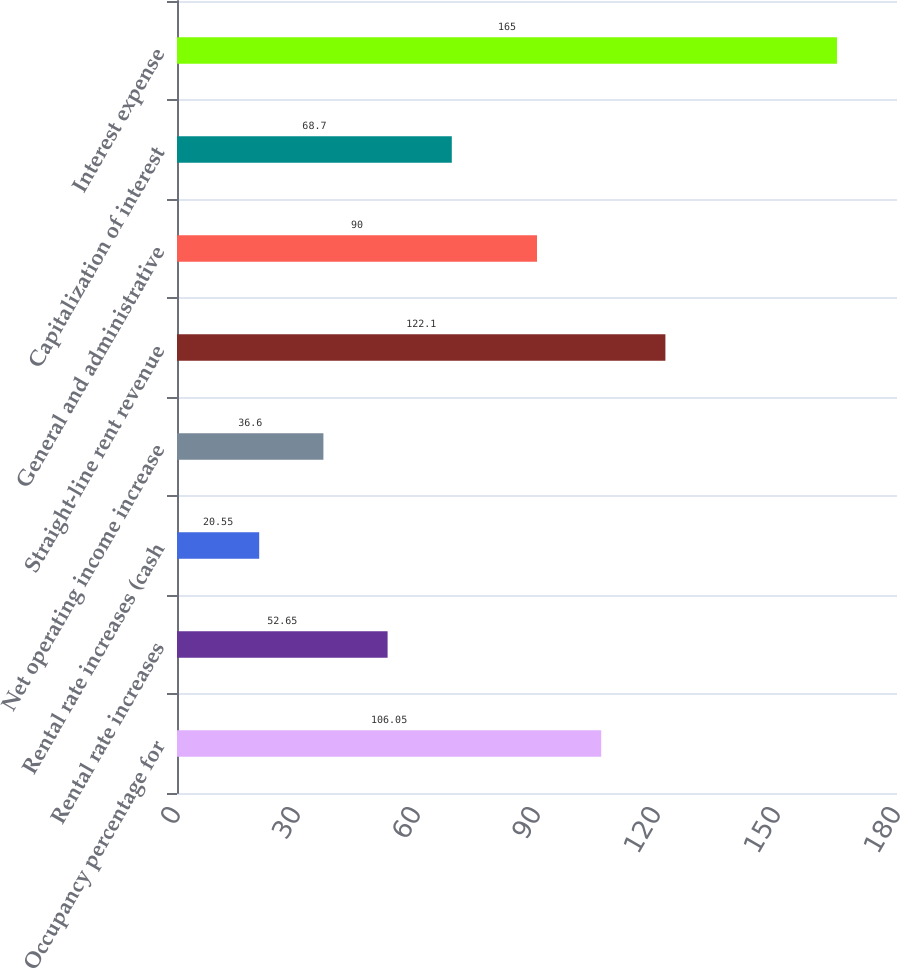<chart> <loc_0><loc_0><loc_500><loc_500><bar_chart><fcel>Occupancy percentage for<fcel>Rental rate increases<fcel>Rental rate increases (cash<fcel>Net operating income increase<fcel>Straight-line rent revenue<fcel>General and administrative<fcel>Capitalization of interest<fcel>Interest expense<nl><fcel>106.05<fcel>52.65<fcel>20.55<fcel>36.6<fcel>122.1<fcel>90<fcel>68.7<fcel>165<nl></chart> 